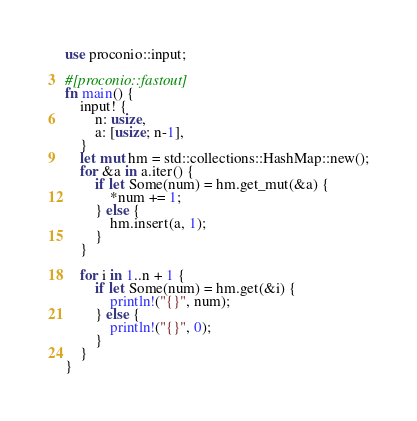<code> <loc_0><loc_0><loc_500><loc_500><_Rust_>use proconio::input;

#[proconio::fastout]
fn main() {
    input! {
        n: usize,
        a: [usize; n-1],
    }
    let mut hm = std::collections::HashMap::new();
    for &a in a.iter() {
        if let Some(num) = hm.get_mut(&a) {
            *num += 1;
        } else {
            hm.insert(a, 1);
        }
    }

    for i in 1..n + 1 {
        if let Some(num) = hm.get(&i) {
            println!("{}", num);
        } else {
            println!("{}", 0);
        }
    }
}
</code> 